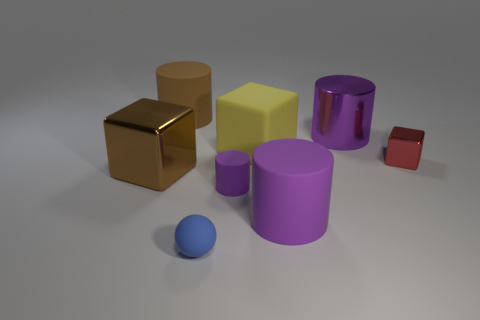What is the color of the block that is the same material as the small sphere?
Your answer should be compact. Yellow. There is a big matte object in front of the yellow object; what is its color?
Your answer should be compact. Purple. How many large matte cubes have the same color as the tiny rubber ball?
Your answer should be compact. 0. Is the number of big brown cubes that are to the right of the tiny red metallic thing less than the number of large rubber cylinders right of the metallic cylinder?
Offer a very short reply. No. There is a red metallic block; how many brown things are to the left of it?
Keep it short and to the point. 2. Is there a big red object that has the same material as the small ball?
Keep it short and to the point. No. Is the number of large metallic cylinders in front of the rubber cube greater than the number of large brown objects that are right of the large brown metal object?
Provide a succinct answer. No. The blue matte thing has what size?
Offer a terse response. Small. The tiny rubber object to the right of the tiny blue matte thing has what shape?
Ensure brevity in your answer.  Cylinder. Do the small blue matte object and the big yellow object have the same shape?
Provide a short and direct response. No. 